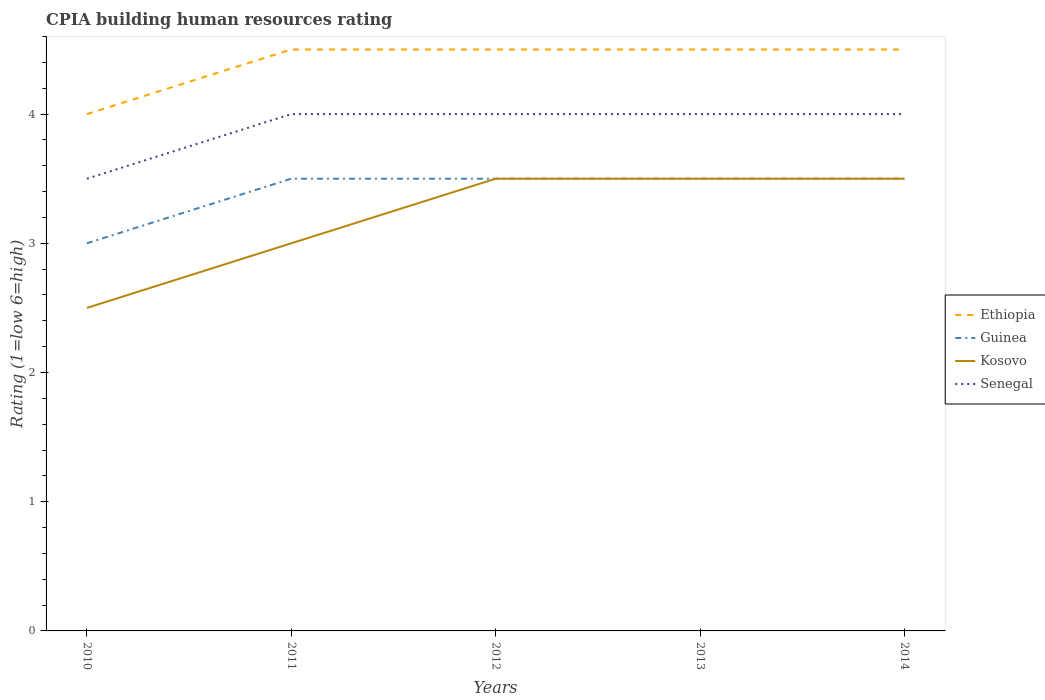How many different coloured lines are there?
Give a very brief answer. 4. Is the number of lines equal to the number of legend labels?
Provide a succinct answer. Yes. What is the total CPIA rating in Senegal in the graph?
Offer a terse response. -0.5. What is the difference between the highest and the second highest CPIA rating in Ethiopia?
Your response must be concise. 0.5. What is the difference between the highest and the lowest CPIA rating in Guinea?
Your answer should be compact. 4. Does the graph contain grids?
Offer a very short reply. No. What is the title of the graph?
Your response must be concise. CPIA building human resources rating. Does "Tanzania" appear as one of the legend labels in the graph?
Keep it short and to the point. No. What is the label or title of the X-axis?
Give a very brief answer. Years. What is the Rating (1=low 6=high) of Ethiopia in 2010?
Provide a succinct answer. 4. What is the Rating (1=low 6=high) of Guinea in 2010?
Make the answer very short. 3. What is the Rating (1=low 6=high) of Kosovo in 2010?
Offer a very short reply. 2.5. What is the Rating (1=low 6=high) of Senegal in 2010?
Offer a terse response. 3.5. What is the Rating (1=low 6=high) in Ethiopia in 2011?
Ensure brevity in your answer.  4.5. What is the Rating (1=low 6=high) in Guinea in 2011?
Offer a very short reply. 3.5. What is the Rating (1=low 6=high) in Senegal in 2011?
Offer a very short reply. 4. What is the Rating (1=low 6=high) in Ethiopia in 2012?
Keep it short and to the point. 4.5. What is the Rating (1=low 6=high) in Kosovo in 2012?
Provide a succinct answer. 3.5. What is the Rating (1=low 6=high) of Senegal in 2012?
Provide a succinct answer. 4. What is the Rating (1=low 6=high) of Guinea in 2013?
Ensure brevity in your answer.  3.5. What is the Rating (1=low 6=high) in Kosovo in 2013?
Keep it short and to the point. 3.5. What is the Rating (1=low 6=high) in Senegal in 2013?
Your response must be concise. 4. What is the Rating (1=low 6=high) in Kosovo in 2014?
Your answer should be compact. 3.5. What is the Rating (1=low 6=high) in Senegal in 2014?
Make the answer very short. 4. Across all years, what is the maximum Rating (1=low 6=high) of Guinea?
Offer a very short reply. 3.5. What is the total Rating (1=low 6=high) of Senegal in the graph?
Keep it short and to the point. 19.5. What is the difference between the Rating (1=low 6=high) in Ethiopia in 2010 and that in 2011?
Keep it short and to the point. -0.5. What is the difference between the Rating (1=low 6=high) of Kosovo in 2010 and that in 2012?
Your answer should be very brief. -1. What is the difference between the Rating (1=low 6=high) in Guinea in 2010 and that in 2013?
Give a very brief answer. -0.5. What is the difference between the Rating (1=low 6=high) in Senegal in 2010 and that in 2013?
Offer a terse response. -0.5. What is the difference between the Rating (1=low 6=high) in Ethiopia in 2010 and that in 2014?
Provide a short and direct response. -0.5. What is the difference between the Rating (1=low 6=high) of Kosovo in 2010 and that in 2014?
Make the answer very short. -1. What is the difference between the Rating (1=low 6=high) of Guinea in 2011 and that in 2012?
Your answer should be compact. 0. What is the difference between the Rating (1=low 6=high) of Kosovo in 2011 and that in 2012?
Offer a terse response. -0.5. What is the difference between the Rating (1=low 6=high) in Senegal in 2011 and that in 2012?
Your answer should be very brief. 0. What is the difference between the Rating (1=low 6=high) of Guinea in 2011 and that in 2013?
Your response must be concise. 0. What is the difference between the Rating (1=low 6=high) in Kosovo in 2011 and that in 2013?
Give a very brief answer. -0.5. What is the difference between the Rating (1=low 6=high) in Guinea in 2011 and that in 2014?
Your answer should be compact. 0. What is the difference between the Rating (1=low 6=high) of Kosovo in 2011 and that in 2014?
Your answer should be compact. -0.5. What is the difference between the Rating (1=low 6=high) in Guinea in 2012 and that in 2013?
Provide a succinct answer. 0. What is the difference between the Rating (1=low 6=high) in Senegal in 2012 and that in 2013?
Your response must be concise. 0. What is the difference between the Rating (1=low 6=high) in Ethiopia in 2012 and that in 2014?
Keep it short and to the point. 0. What is the difference between the Rating (1=low 6=high) in Guinea in 2012 and that in 2014?
Ensure brevity in your answer.  0. What is the difference between the Rating (1=low 6=high) of Kosovo in 2012 and that in 2014?
Keep it short and to the point. 0. What is the difference between the Rating (1=low 6=high) of Ethiopia in 2013 and that in 2014?
Your response must be concise. 0. What is the difference between the Rating (1=low 6=high) of Guinea in 2013 and that in 2014?
Give a very brief answer. 0. What is the difference between the Rating (1=low 6=high) in Kosovo in 2010 and the Rating (1=low 6=high) in Senegal in 2011?
Offer a very short reply. -1.5. What is the difference between the Rating (1=low 6=high) in Ethiopia in 2010 and the Rating (1=low 6=high) in Guinea in 2012?
Your answer should be compact. 0.5. What is the difference between the Rating (1=low 6=high) in Guinea in 2010 and the Rating (1=low 6=high) in Senegal in 2012?
Your answer should be very brief. -1. What is the difference between the Rating (1=low 6=high) in Kosovo in 2010 and the Rating (1=low 6=high) in Senegal in 2012?
Provide a short and direct response. -1.5. What is the difference between the Rating (1=low 6=high) of Ethiopia in 2010 and the Rating (1=low 6=high) of Senegal in 2013?
Offer a terse response. 0. What is the difference between the Rating (1=low 6=high) in Guinea in 2010 and the Rating (1=low 6=high) in Senegal in 2013?
Give a very brief answer. -1. What is the difference between the Rating (1=low 6=high) of Ethiopia in 2010 and the Rating (1=low 6=high) of Kosovo in 2014?
Your response must be concise. 0.5. What is the difference between the Rating (1=low 6=high) in Guinea in 2010 and the Rating (1=low 6=high) in Kosovo in 2014?
Give a very brief answer. -0.5. What is the difference between the Rating (1=low 6=high) in Kosovo in 2010 and the Rating (1=low 6=high) in Senegal in 2014?
Provide a short and direct response. -1.5. What is the difference between the Rating (1=low 6=high) in Ethiopia in 2011 and the Rating (1=low 6=high) in Kosovo in 2012?
Your answer should be very brief. 1. What is the difference between the Rating (1=low 6=high) of Ethiopia in 2011 and the Rating (1=low 6=high) of Senegal in 2012?
Your answer should be very brief. 0.5. What is the difference between the Rating (1=low 6=high) in Guinea in 2011 and the Rating (1=low 6=high) in Kosovo in 2012?
Offer a terse response. 0. What is the difference between the Rating (1=low 6=high) of Guinea in 2011 and the Rating (1=low 6=high) of Senegal in 2012?
Your answer should be very brief. -0.5. What is the difference between the Rating (1=low 6=high) in Kosovo in 2011 and the Rating (1=low 6=high) in Senegal in 2012?
Make the answer very short. -1. What is the difference between the Rating (1=low 6=high) in Ethiopia in 2011 and the Rating (1=low 6=high) in Kosovo in 2013?
Provide a short and direct response. 1. What is the difference between the Rating (1=low 6=high) in Guinea in 2011 and the Rating (1=low 6=high) in Kosovo in 2013?
Your answer should be compact. 0. What is the difference between the Rating (1=low 6=high) in Guinea in 2011 and the Rating (1=low 6=high) in Senegal in 2013?
Your response must be concise. -0.5. What is the difference between the Rating (1=low 6=high) in Kosovo in 2011 and the Rating (1=low 6=high) in Senegal in 2013?
Your response must be concise. -1. What is the difference between the Rating (1=low 6=high) of Ethiopia in 2011 and the Rating (1=low 6=high) of Guinea in 2014?
Provide a succinct answer. 1. What is the difference between the Rating (1=low 6=high) of Ethiopia in 2011 and the Rating (1=low 6=high) of Kosovo in 2014?
Offer a very short reply. 1. What is the difference between the Rating (1=low 6=high) of Ethiopia in 2011 and the Rating (1=low 6=high) of Senegal in 2014?
Provide a short and direct response. 0.5. What is the difference between the Rating (1=low 6=high) in Guinea in 2011 and the Rating (1=low 6=high) in Kosovo in 2014?
Your response must be concise. 0. What is the difference between the Rating (1=low 6=high) of Ethiopia in 2012 and the Rating (1=low 6=high) of Guinea in 2013?
Your answer should be very brief. 1. What is the difference between the Rating (1=low 6=high) in Ethiopia in 2012 and the Rating (1=low 6=high) in Kosovo in 2013?
Offer a very short reply. 1. What is the difference between the Rating (1=low 6=high) in Ethiopia in 2012 and the Rating (1=low 6=high) in Senegal in 2013?
Make the answer very short. 0.5. What is the difference between the Rating (1=low 6=high) of Guinea in 2012 and the Rating (1=low 6=high) of Kosovo in 2013?
Provide a succinct answer. 0. What is the difference between the Rating (1=low 6=high) in Kosovo in 2012 and the Rating (1=low 6=high) in Senegal in 2013?
Give a very brief answer. -0.5. What is the difference between the Rating (1=low 6=high) in Ethiopia in 2012 and the Rating (1=low 6=high) in Guinea in 2014?
Give a very brief answer. 1. What is the difference between the Rating (1=low 6=high) of Ethiopia in 2012 and the Rating (1=low 6=high) of Senegal in 2014?
Your answer should be very brief. 0.5. What is the difference between the Rating (1=low 6=high) of Guinea in 2012 and the Rating (1=low 6=high) of Kosovo in 2014?
Make the answer very short. 0. What is the difference between the Rating (1=low 6=high) in Ethiopia in 2013 and the Rating (1=low 6=high) in Guinea in 2014?
Make the answer very short. 1. What is the difference between the Rating (1=low 6=high) in Ethiopia in 2013 and the Rating (1=low 6=high) in Senegal in 2014?
Give a very brief answer. 0.5. What is the difference between the Rating (1=low 6=high) of Guinea in 2013 and the Rating (1=low 6=high) of Kosovo in 2014?
Ensure brevity in your answer.  0. What is the difference between the Rating (1=low 6=high) in Guinea in 2013 and the Rating (1=low 6=high) in Senegal in 2014?
Provide a succinct answer. -0.5. What is the average Rating (1=low 6=high) of Senegal per year?
Keep it short and to the point. 3.9. In the year 2010, what is the difference between the Rating (1=low 6=high) in Ethiopia and Rating (1=low 6=high) in Senegal?
Keep it short and to the point. 0.5. In the year 2010, what is the difference between the Rating (1=low 6=high) of Guinea and Rating (1=low 6=high) of Kosovo?
Your response must be concise. 0.5. In the year 2010, what is the difference between the Rating (1=low 6=high) of Guinea and Rating (1=low 6=high) of Senegal?
Your answer should be compact. -0.5. In the year 2012, what is the difference between the Rating (1=low 6=high) of Ethiopia and Rating (1=low 6=high) of Senegal?
Your response must be concise. 0.5. In the year 2012, what is the difference between the Rating (1=low 6=high) of Kosovo and Rating (1=low 6=high) of Senegal?
Keep it short and to the point. -0.5. In the year 2013, what is the difference between the Rating (1=low 6=high) of Ethiopia and Rating (1=low 6=high) of Guinea?
Offer a terse response. 1. In the year 2013, what is the difference between the Rating (1=low 6=high) of Ethiopia and Rating (1=low 6=high) of Kosovo?
Give a very brief answer. 1. In the year 2013, what is the difference between the Rating (1=low 6=high) of Ethiopia and Rating (1=low 6=high) of Senegal?
Make the answer very short. 0.5. In the year 2014, what is the difference between the Rating (1=low 6=high) in Ethiopia and Rating (1=low 6=high) in Guinea?
Provide a short and direct response. 1. In the year 2014, what is the difference between the Rating (1=low 6=high) of Ethiopia and Rating (1=low 6=high) of Kosovo?
Your answer should be compact. 1. In the year 2014, what is the difference between the Rating (1=low 6=high) in Guinea and Rating (1=low 6=high) in Kosovo?
Offer a very short reply. 0. In the year 2014, what is the difference between the Rating (1=low 6=high) of Guinea and Rating (1=low 6=high) of Senegal?
Keep it short and to the point. -0.5. What is the ratio of the Rating (1=low 6=high) in Guinea in 2010 to that in 2011?
Your answer should be compact. 0.86. What is the ratio of the Rating (1=low 6=high) of Kosovo in 2010 to that in 2011?
Provide a short and direct response. 0.83. What is the ratio of the Rating (1=low 6=high) of Senegal in 2010 to that in 2011?
Your answer should be compact. 0.88. What is the ratio of the Rating (1=low 6=high) of Kosovo in 2010 to that in 2012?
Give a very brief answer. 0.71. What is the ratio of the Rating (1=low 6=high) of Ethiopia in 2010 to that in 2013?
Provide a succinct answer. 0.89. What is the ratio of the Rating (1=low 6=high) in Kosovo in 2010 to that in 2013?
Your answer should be compact. 0.71. What is the ratio of the Rating (1=low 6=high) in Senegal in 2010 to that in 2013?
Give a very brief answer. 0.88. What is the ratio of the Rating (1=low 6=high) of Ethiopia in 2010 to that in 2014?
Your response must be concise. 0.89. What is the ratio of the Rating (1=low 6=high) in Senegal in 2010 to that in 2014?
Give a very brief answer. 0.88. What is the ratio of the Rating (1=low 6=high) in Guinea in 2011 to that in 2012?
Your answer should be very brief. 1. What is the ratio of the Rating (1=low 6=high) of Senegal in 2011 to that in 2012?
Offer a terse response. 1. What is the ratio of the Rating (1=low 6=high) of Ethiopia in 2011 to that in 2014?
Give a very brief answer. 1. What is the ratio of the Rating (1=low 6=high) in Kosovo in 2011 to that in 2014?
Your answer should be compact. 0.86. What is the ratio of the Rating (1=low 6=high) in Guinea in 2012 to that in 2013?
Offer a terse response. 1. What is the ratio of the Rating (1=low 6=high) in Kosovo in 2012 to that in 2013?
Give a very brief answer. 1. What is the ratio of the Rating (1=low 6=high) in Ethiopia in 2012 to that in 2014?
Make the answer very short. 1. What is the difference between the highest and the second highest Rating (1=low 6=high) in Guinea?
Keep it short and to the point. 0. What is the difference between the highest and the second highest Rating (1=low 6=high) of Kosovo?
Make the answer very short. 0. What is the difference between the highest and the lowest Rating (1=low 6=high) of Ethiopia?
Ensure brevity in your answer.  0.5. 